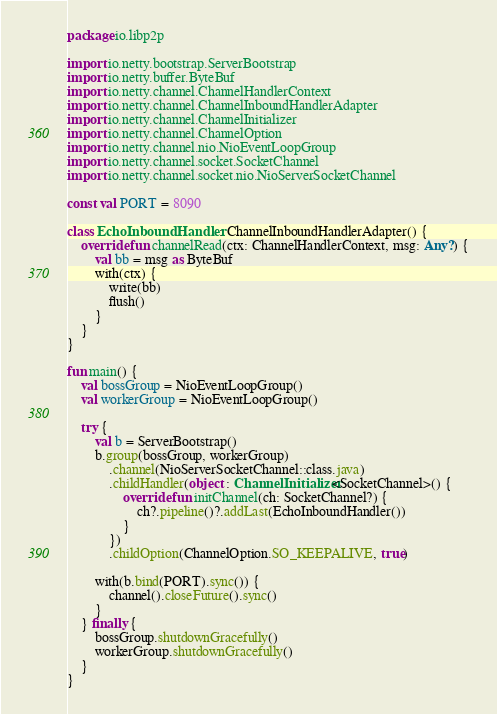Convert code to text. <code><loc_0><loc_0><loc_500><loc_500><_Kotlin_>package io.libp2p

import io.netty.bootstrap.ServerBootstrap
import io.netty.buffer.ByteBuf
import io.netty.channel.ChannelHandlerContext
import io.netty.channel.ChannelInboundHandlerAdapter
import io.netty.channel.ChannelInitializer
import io.netty.channel.ChannelOption
import io.netty.channel.nio.NioEventLoopGroup
import io.netty.channel.socket.SocketChannel
import io.netty.channel.socket.nio.NioServerSocketChannel

const val PORT = 8090

class EchoInboundHandler : ChannelInboundHandlerAdapter() {
    override fun channelRead(ctx: ChannelHandlerContext, msg: Any?) {
        val bb = msg as ByteBuf
        with(ctx) {
            write(bb)
            flush()
        }
    }
}

fun main() {
    val bossGroup = NioEventLoopGroup()
    val workerGroup = NioEventLoopGroup()

    try {
        val b = ServerBootstrap()
        b.group(bossGroup, workerGroup)
            .channel(NioServerSocketChannel::class.java)
            .childHandler(object : ChannelInitializer<SocketChannel>() {
                override fun initChannel(ch: SocketChannel?) {
                    ch?.pipeline()?.addLast(EchoInboundHandler())
                }
            })
            .childOption(ChannelOption.SO_KEEPALIVE, true)

        with(b.bind(PORT).sync()) {
            channel().closeFuture().sync()
        }
    } finally {
        bossGroup.shutdownGracefully()
        workerGroup.shutdownGracefully()
    }
}
</code> 